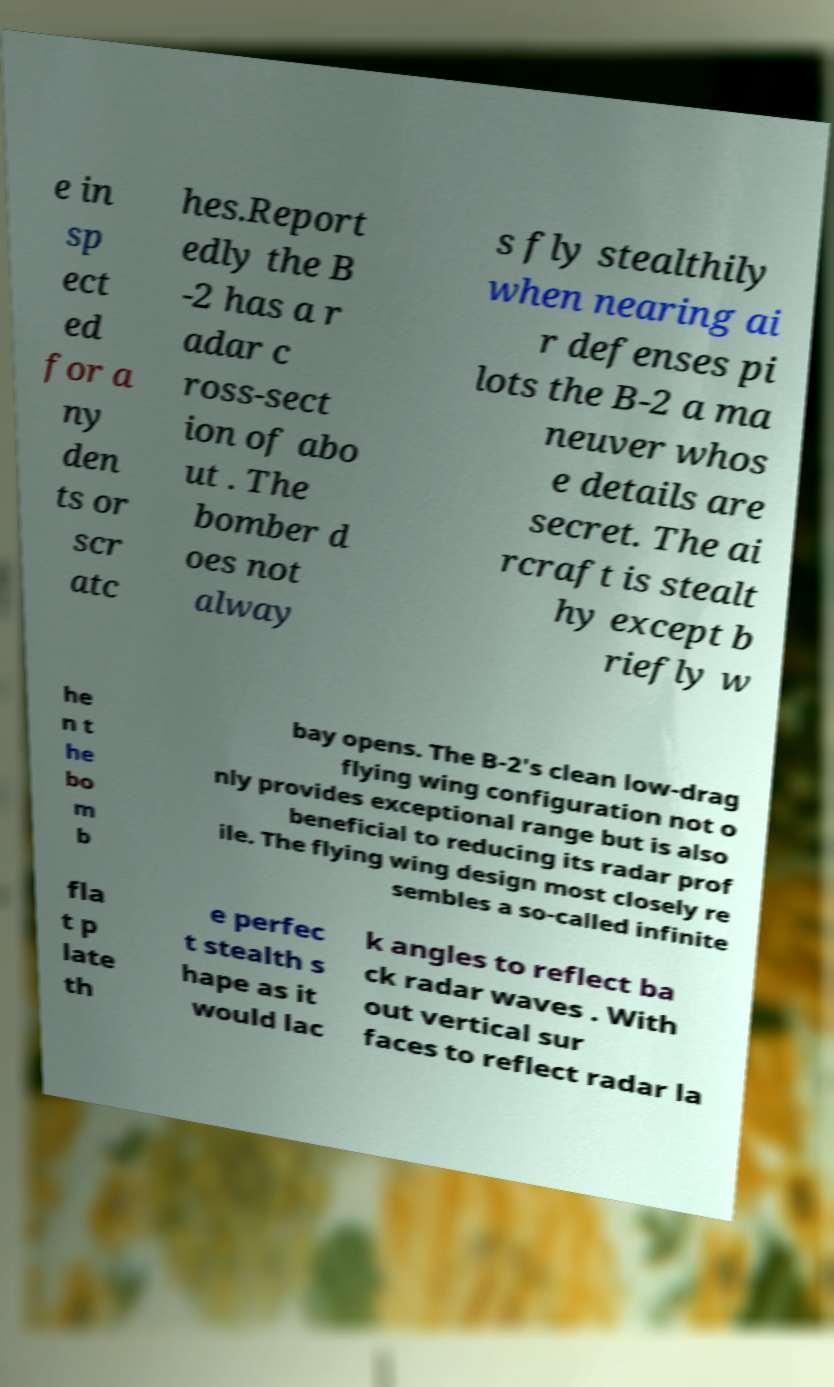Please identify and transcribe the text found in this image. e in sp ect ed for a ny den ts or scr atc hes.Report edly the B -2 has a r adar c ross-sect ion of abo ut . The bomber d oes not alway s fly stealthily when nearing ai r defenses pi lots the B-2 a ma neuver whos e details are secret. The ai rcraft is stealt hy except b riefly w he n t he bo m b bay opens. The B-2's clean low-drag flying wing configuration not o nly provides exceptional range but is also beneficial to reducing its radar prof ile. The flying wing design most closely re sembles a so-called infinite fla t p late th e perfec t stealth s hape as it would lac k angles to reflect ba ck radar waves . With out vertical sur faces to reflect radar la 